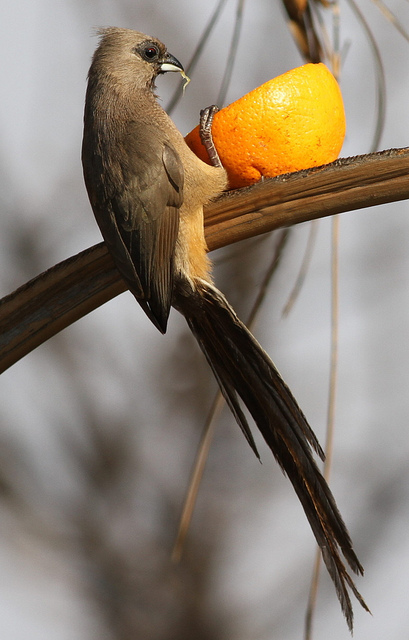<image>What kind of bird is this? I don't know what kind of bird this is. It could be a hummingbird, woodpecker, waxwing, flycatcher, chimney swift, long tailed bird, parakeet, or cardinal. What kind of bird is this? I don't know what kind of bird it is. It could be a hummingbird, woodpecker, brown bird, waxwing, flycatcher, chimney swift, long tailed bird, parakeet, or cardinal. 